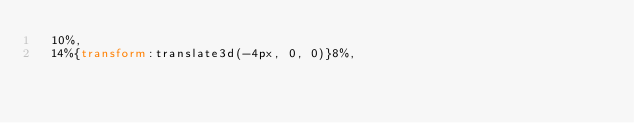Convert code to text. <code><loc_0><loc_0><loc_500><loc_500><_CSS_>  10%,
  14%{transform:translate3d(-4px, 0, 0)}8%,</code> 